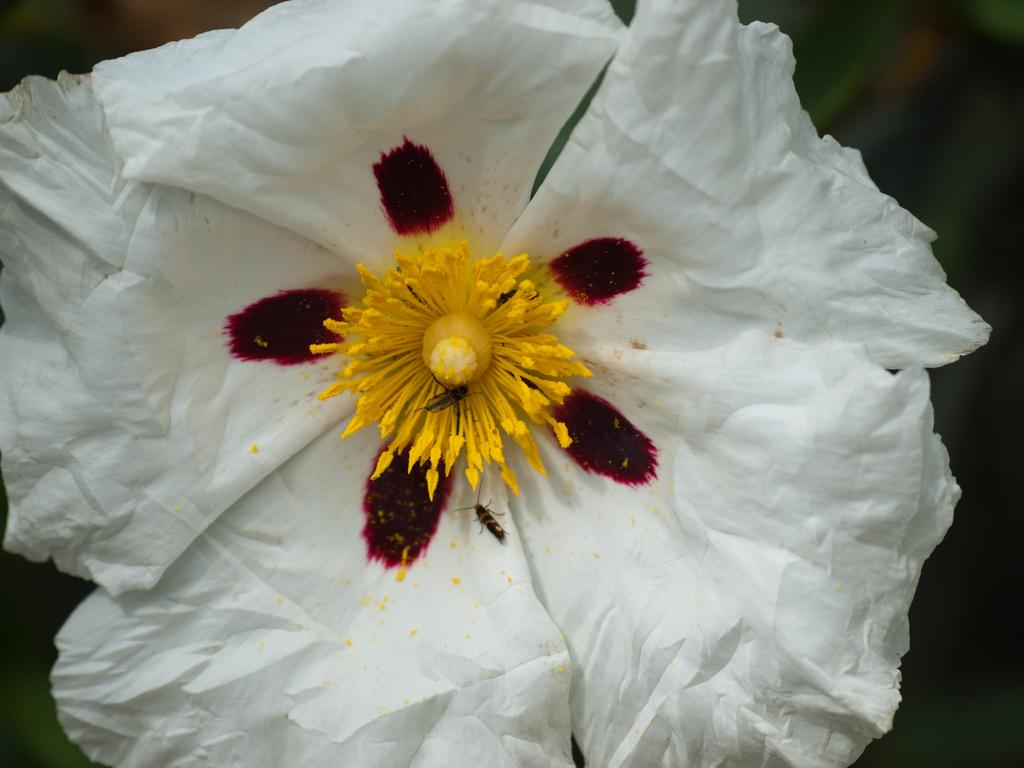What is the main subject of the picture? The main subject of the picture is a flower. Can you describe the color of the flower? The flower is white. What color is the background of the picture? The background of the picture is black. How many needles are attached to the flower in the image? There are no needles present in the image; it features a white flower against a black background. 